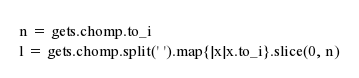Convert code to text. <code><loc_0><loc_0><loc_500><loc_500><_Ruby_>n = gets.chomp.to_i
l = gets.chomp.split(' ').map{|x|x.to_i}.slice(0, n)</code> 